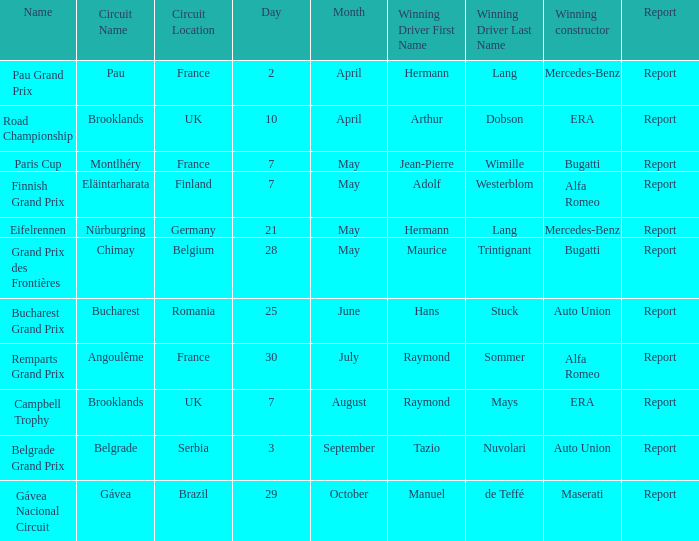Tell me the report for 10 april Report. Parse the full table. {'header': ['Name', 'Circuit Name', 'Circuit Location', 'Day', 'Month', 'Winning Driver First Name', 'Winning Driver Last Name', 'Winning constructor', 'Report'], 'rows': [['Pau Grand Prix', 'Pau', 'France', '2', 'April', 'Hermann', 'Lang', 'Mercedes-Benz', 'Report'], ['Road Championship', 'Brooklands', 'UK', '10', 'April', 'Arthur', 'Dobson', 'ERA', 'Report'], ['Paris Cup', 'Montlhéry', 'France', '7', 'May', 'Jean-Pierre', 'Wimille', 'Bugatti', 'Report'], ['Finnish Grand Prix', 'Eläintarharata', 'Finland', '7', 'May', 'Adolf', 'Westerblom', 'Alfa Romeo', 'Report'], ['Eifelrennen', 'Nürburgring', 'Germany', '21', 'May', 'Hermann', 'Lang', 'Mercedes-Benz', 'Report'], ['Grand Prix des Frontières', 'Chimay', 'Belgium', '28', 'May', 'Maurice', 'Trintignant', 'Bugatti', 'Report'], ['Bucharest Grand Prix', 'Bucharest', 'Romania', '25', 'June', 'Hans', 'Stuck', 'Auto Union', 'Report'], ['Remparts Grand Prix', 'Angoulême', 'France', '30', 'July', 'Raymond', 'Sommer', 'Alfa Romeo', 'Report'], ['Campbell Trophy', 'Brooklands', 'UK', '7', 'August', 'Raymond', 'Mays', 'ERA', 'Report'], ['Belgrade Grand Prix', 'Belgrade', 'Serbia', '3', 'September', 'Tazio', 'Nuvolari', 'Auto Union', 'Report'], ['Gávea Nacional Circuit', 'Gávea', 'Brazil', '29', 'October', 'Manuel', 'de Teffé', 'Maserati', 'Report']]} 